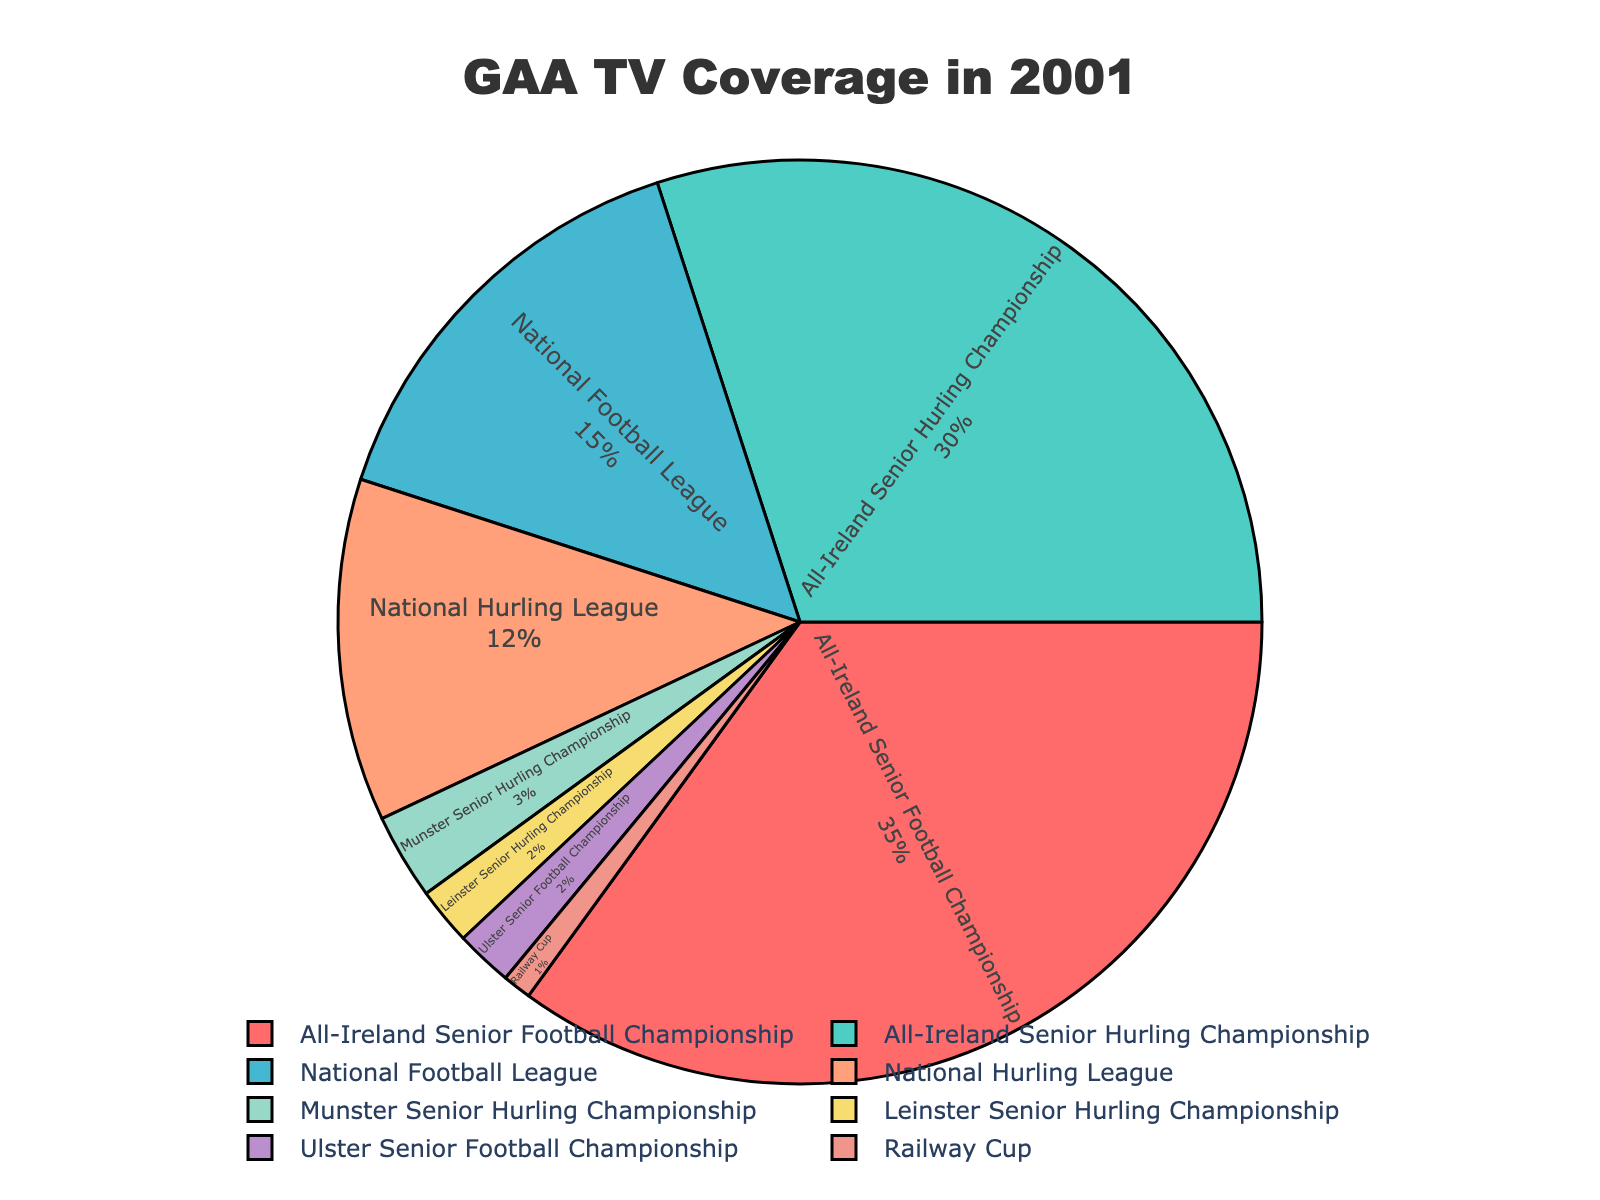What percentage of televised GAA matches in 2001 were from the All-Ireland Senior Football Championship? The pie chart indicates that the All-Ireland Senior Football Championship accounted for 35% of the televised matches in 2001.
Answer: 35% Which competition had more televised matches: the National Football League or the National Hurling League? The chart shows the National Football League had 15% while the National Hurling League had 12%, so the National Football League had more televised matches.
Answer: National Football League What is the combined percentage of televised matches for the Munster and Leinster Senior Hurling Championships? The pie chart shows Munster Senior Hurling Championship at 3% and Leinster Senior Hurling Championship at 2%. Adding these together, 3% + 2% gives a combined percentage.
Answer: 5% How does the coverage of the Ulster Senior Football Championship compare to the Railway Cup? By looking at the pie chart, the Ulster Senior Football Championship has 2% coverage, and the Railway Cup has 1% coverage. Thus, the Ulster Senior Football Championship had twice the coverage of the Railway Cup.
Answer: Ulster Senior Football Championship Which competition had the least amount of televised coverage? The pie chart shows the Railway Cup with the smallest slice at 1%, making it the competition with the least coverage.
Answer: Railway Cup Among the competitions with over 10% coverage, what is their total combined coverage? All-Ireland Senior Football Championship (35%), All-Ireland Senior Hurling Championship (30%), National Football League (15%), and National Hurling League (12%) all have coverage over 10%. Adding them together: 35% + 30% + 15% + 12% equals 92%.
Answer: 92% How much higher is the percentage of All-Ireland Senior Football Championship coverage compared to Munster Senior Hurling Championship? The pie chart indicates the All-Ireland Senior Football Championship had 35% coverage while the Munster Senior Hurling Championship had 3%. The difference is 35% - 3% = 32%.
Answer: 32% If you combine the National Football League and National Hurling League percentages, how do they compare to the All-Ireland Senior Hurling Championship coverage? The pie chart shows the National Football League at 15% and the National Hurling League at 12%. Their combined coverage is 15% + 12% = 27%, which is less than the All-Ireland Senior Hurling Championship coverage of 30%.
Answer: Less than Which competitions together account for exactly half of the total coverage being analyzed? The total of the All-Ireland Senior Football Championship (35%) and All-Ireland Senior Hurling Championship (30%) equals 65%. Adding the National Football League (15%) gives 80%. The next addition is the National Hurling League (12%), reaching 92%. Finally, adding Munster Senior Hurling Championship (3%) gives 95%, and Leinster Senior Hurling Championship (2%) completes the total 97%. Combinations yielding exactly 50% don't fit exactly because the available percentages add up beyond 50% or fall short of it. Thus, examining proportions, the two highest sum 65% but not double-aligning at 50%. Follow-through confirms this computation.
Answer: Exactly half can't be composed from listed sums 